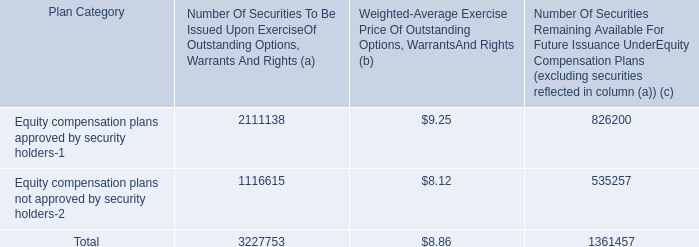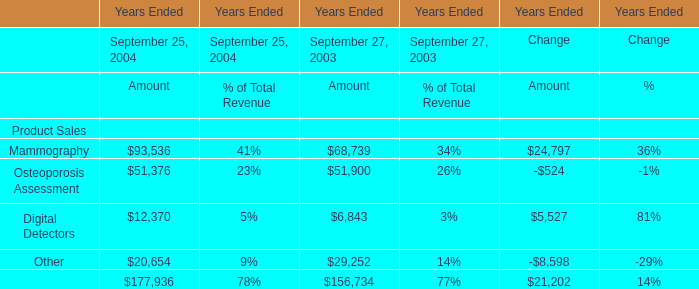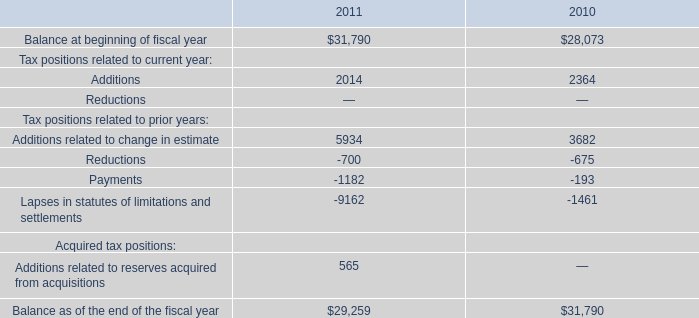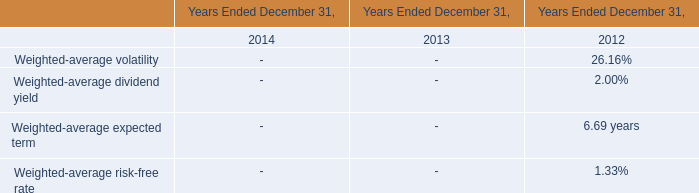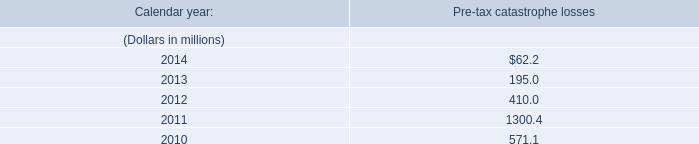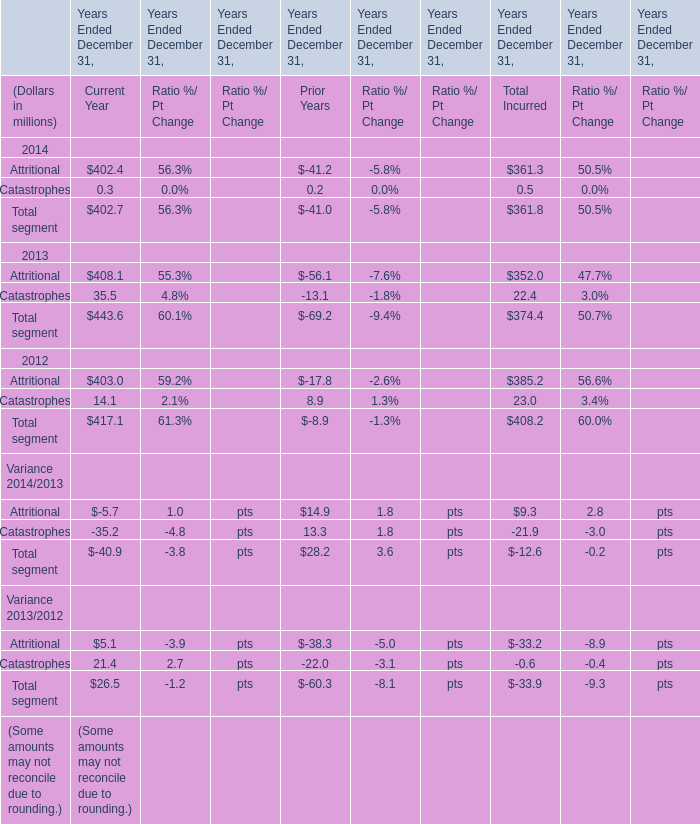Which year Ended December 31 is the value of the amount Total Incurred for Total segment the least? 
Answer: 2014. 